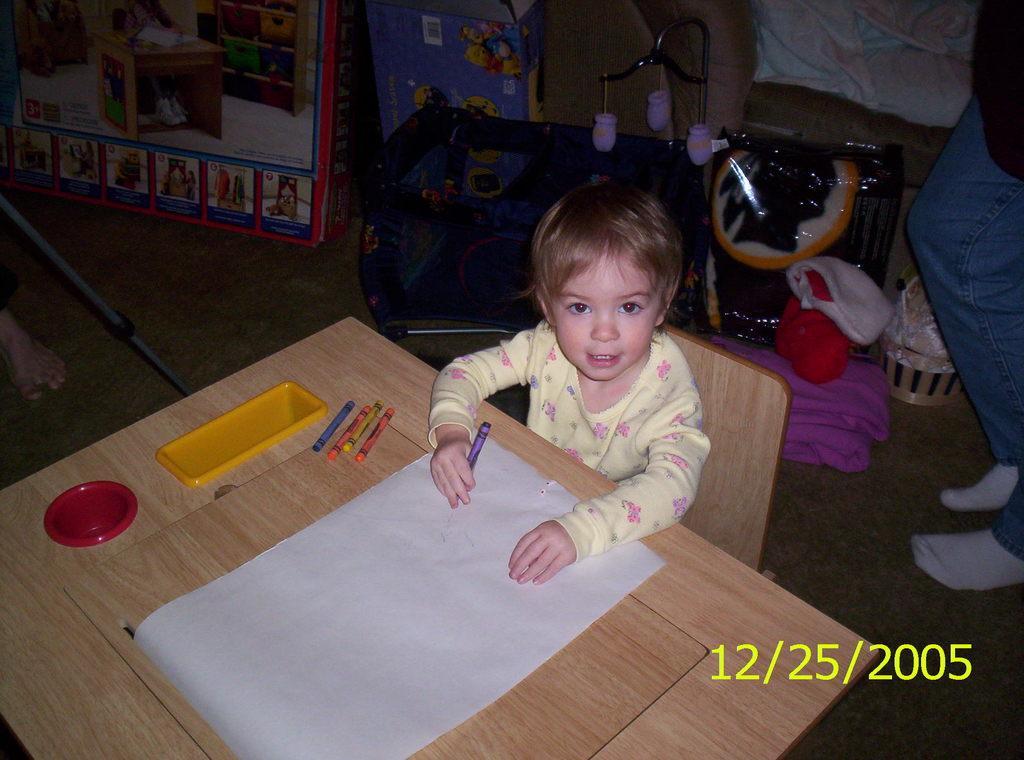In one or two sentences, can you explain what this image depicts? In this picture we can see a kid sitting on the chair. This is table. On the table there is a paper, pencils, and a box. And this is floor. 